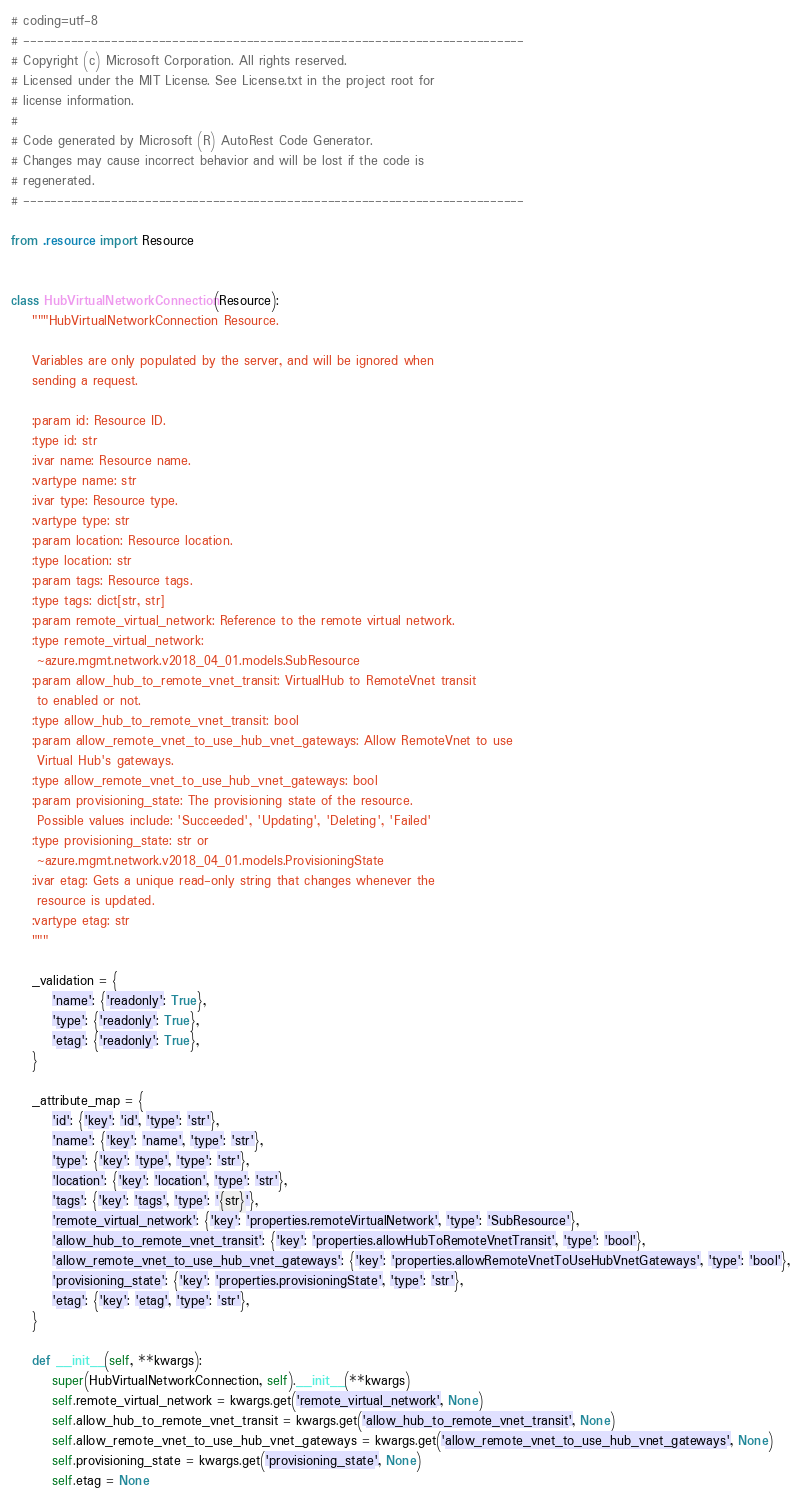Convert code to text. <code><loc_0><loc_0><loc_500><loc_500><_Python_># coding=utf-8
# --------------------------------------------------------------------------
# Copyright (c) Microsoft Corporation. All rights reserved.
# Licensed under the MIT License. See License.txt in the project root for
# license information.
#
# Code generated by Microsoft (R) AutoRest Code Generator.
# Changes may cause incorrect behavior and will be lost if the code is
# regenerated.
# --------------------------------------------------------------------------

from .resource import Resource


class HubVirtualNetworkConnection(Resource):
    """HubVirtualNetworkConnection Resource.

    Variables are only populated by the server, and will be ignored when
    sending a request.

    :param id: Resource ID.
    :type id: str
    :ivar name: Resource name.
    :vartype name: str
    :ivar type: Resource type.
    :vartype type: str
    :param location: Resource location.
    :type location: str
    :param tags: Resource tags.
    :type tags: dict[str, str]
    :param remote_virtual_network: Reference to the remote virtual network.
    :type remote_virtual_network:
     ~azure.mgmt.network.v2018_04_01.models.SubResource
    :param allow_hub_to_remote_vnet_transit: VirtualHub to RemoteVnet transit
     to enabled or not.
    :type allow_hub_to_remote_vnet_transit: bool
    :param allow_remote_vnet_to_use_hub_vnet_gateways: Allow RemoteVnet to use
     Virtual Hub's gateways.
    :type allow_remote_vnet_to_use_hub_vnet_gateways: bool
    :param provisioning_state: The provisioning state of the resource.
     Possible values include: 'Succeeded', 'Updating', 'Deleting', 'Failed'
    :type provisioning_state: str or
     ~azure.mgmt.network.v2018_04_01.models.ProvisioningState
    :ivar etag: Gets a unique read-only string that changes whenever the
     resource is updated.
    :vartype etag: str
    """

    _validation = {
        'name': {'readonly': True},
        'type': {'readonly': True},
        'etag': {'readonly': True},
    }

    _attribute_map = {
        'id': {'key': 'id', 'type': 'str'},
        'name': {'key': 'name', 'type': 'str'},
        'type': {'key': 'type', 'type': 'str'},
        'location': {'key': 'location', 'type': 'str'},
        'tags': {'key': 'tags', 'type': '{str}'},
        'remote_virtual_network': {'key': 'properties.remoteVirtualNetwork', 'type': 'SubResource'},
        'allow_hub_to_remote_vnet_transit': {'key': 'properties.allowHubToRemoteVnetTransit', 'type': 'bool'},
        'allow_remote_vnet_to_use_hub_vnet_gateways': {'key': 'properties.allowRemoteVnetToUseHubVnetGateways', 'type': 'bool'},
        'provisioning_state': {'key': 'properties.provisioningState', 'type': 'str'},
        'etag': {'key': 'etag', 'type': 'str'},
    }

    def __init__(self, **kwargs):
        super(HubVirtualNetworkConnection, self).__init__(**kwargs)
        self.remote_virtual_network = kwargs.get('remote_virtual_network', None)
        self.allow_hub_to_remote_vnet_transit = kwargs.get('allow_hub_to_remote_vnet_transit', None)
        self.allow_remote_vnet_to_use_hub_vnet_gateways = kwargs.get('allow_remote_vnet_to_use_hub_vnet_gateways', None)
        self.provisioning_state = kwargs.get('provisioning_state', None)
        self.etag = None
</code> 